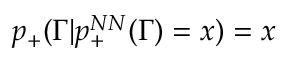<formula> <loc_0><loc_0><loc_500><loc_500>p _ { + } ( \Gamma | p _ { + } ^ { N N } ( \Gamma ) = x ) = x</formula> 